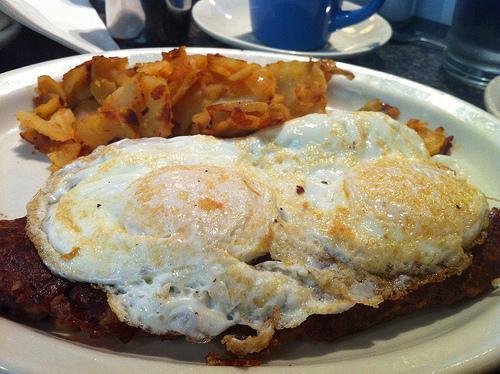How many blue cups?
Give a very brief answer. 1. How many eggs?
Give a very brief answer. 2. 